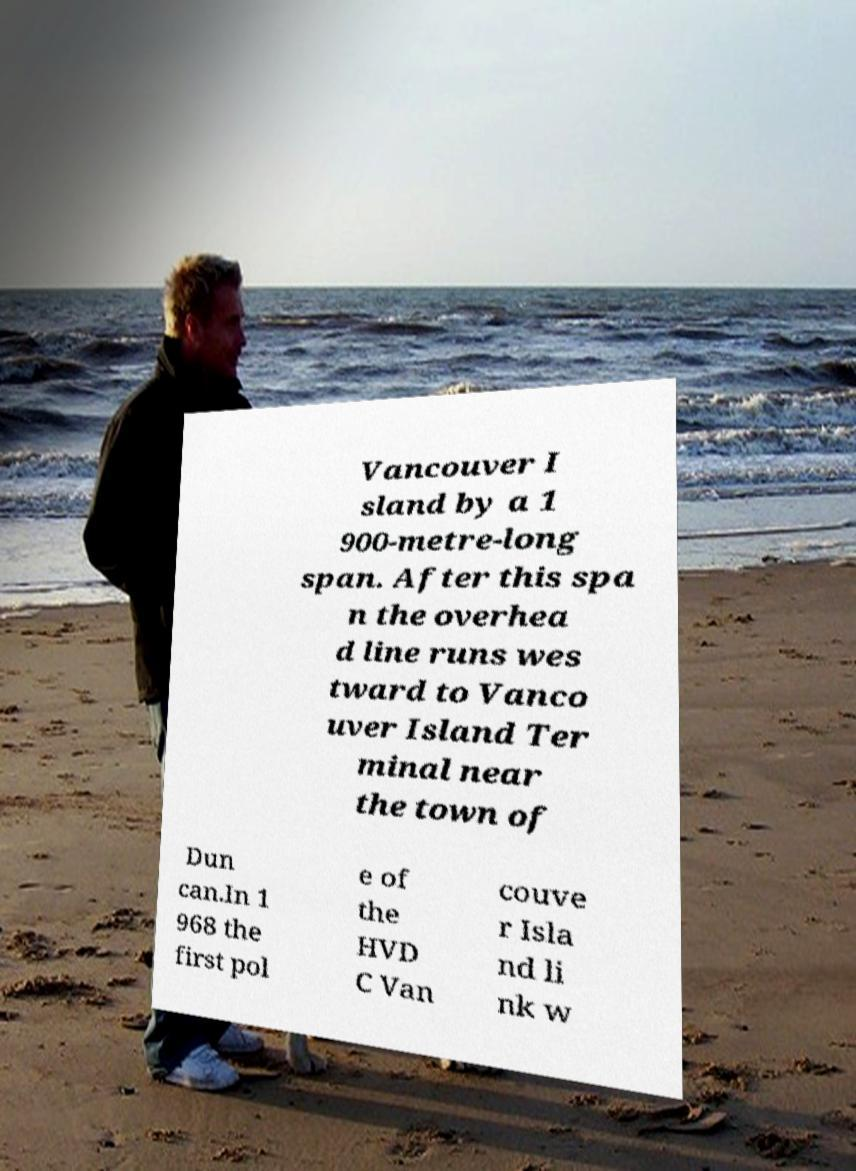I need the written content from this picture converted into text. Can you do that? Vancouver I sland by a 1 900-metre-long span. After this spa n the overhea d line runs wes tward to Vanco uver Island Ter minal near the town of Dun can.In 1 968 the first pol e of the HVD C Van couve r Isla nd li nk w 